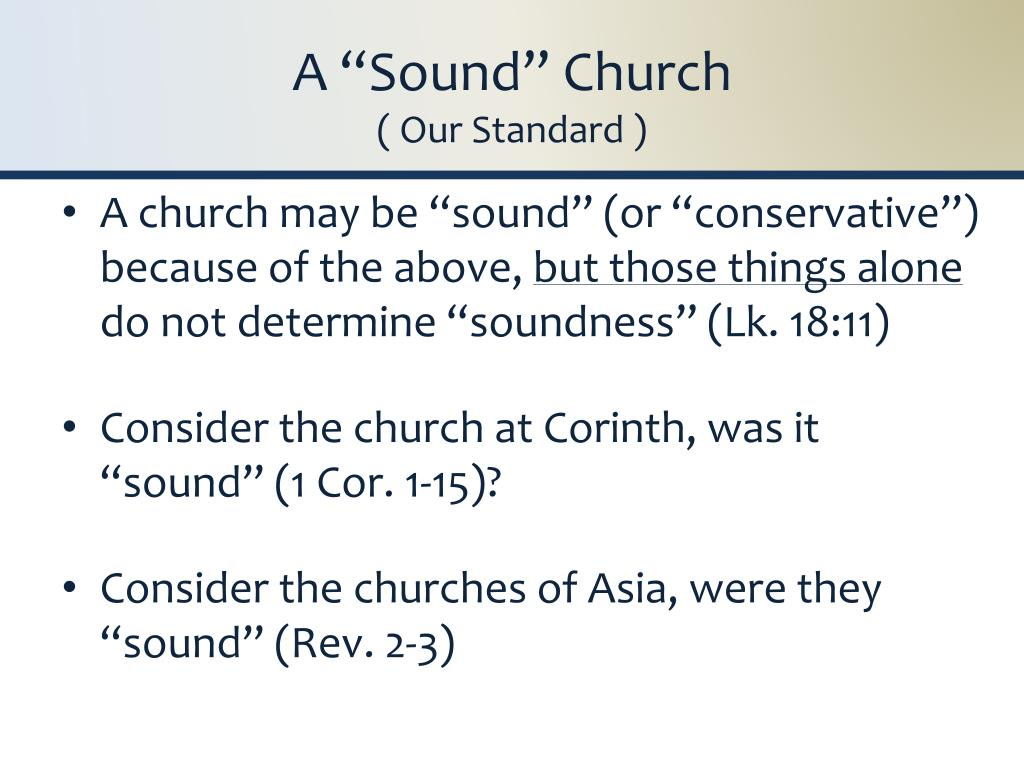What challenges might arise when a church tries to align itself with the 'sound' criteria outlined in Revelation 2-3? Aligning with the 'sound' criteria outlined in Revelation 2-3 can present several challenges, including discerning correct doctrine, resisting societal pressures, and maintaining fervent love and leadership within the church. These chapters highlight the expectations of faithfulness and the pitfalls of deviating from sincere worship and moral standards. Churches may struggle with balancing outreach and maintaining doctrinal purity, handling internal conflicts, and staying resilient in the face of external cultural or moral shifts. Providing continuous biblical education and fostering a strong, supportive community can be effective strategies to overcome these challenges. 